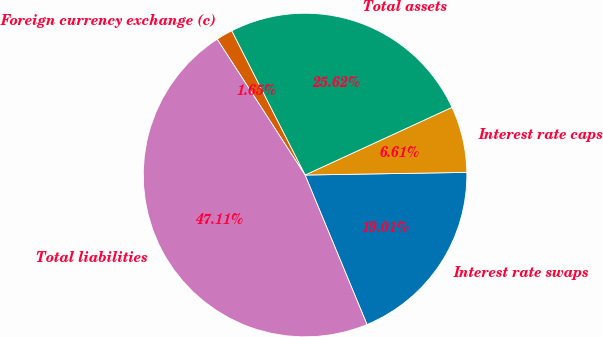<chart> <loc_0><loc_0><loc_500><loc_500><pie_chart><fcel>Interest rate swaps<fcel>Interest rate caps<fcel>Total assets<fcel>Foreign currency exchange (c)<fcel>Total liabilities<nl><fcel>19.01%<fcel>6.61%<fcel>25.62%<fcel>1.65%<fcel>47.11%<nl></chart> 